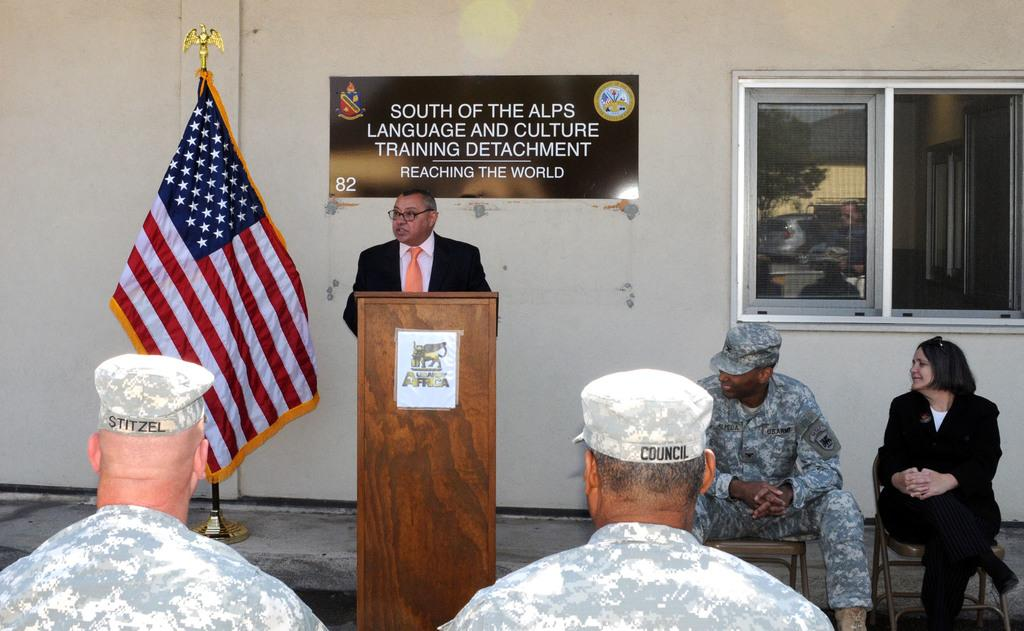What is the main activity taking place in the image? There is a group of people in the image, and a man is standing in front of a podium, suggesting a presentation or speech. How are the other people in the image positioned? Other people are sitting on chairs, indicating that they are likely an audience. What can be seen in the background of the image? There is a flag and a window in the image. What type of treatment is the sister receiving in the image? There is no sister or any indication of treatment in the image. How many balls are visible in the image? There are no balls present in the image. 